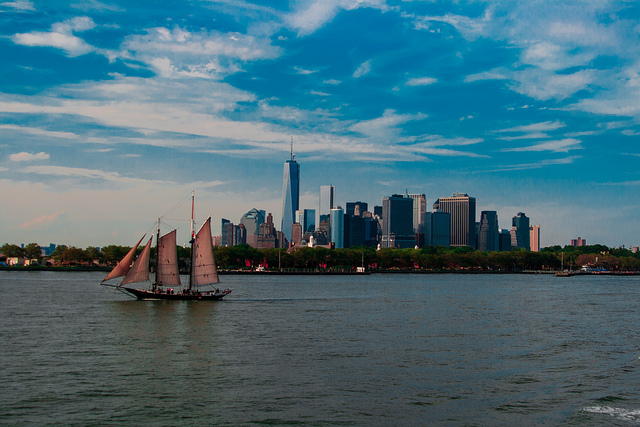<image>What shape would the sail be in if it was unfurled on this boat? It is unknown what shape the sail would be in if it was unfurled on this boat. It could possibly be a rectangle, square, triangle or even a circle. What shape would the sail be in if it was unfurled on this boat? I am not sure what shape the sail would be in if it was unfurled on this boat. It can be seen as a rectangle, square, triangle, or circle. 